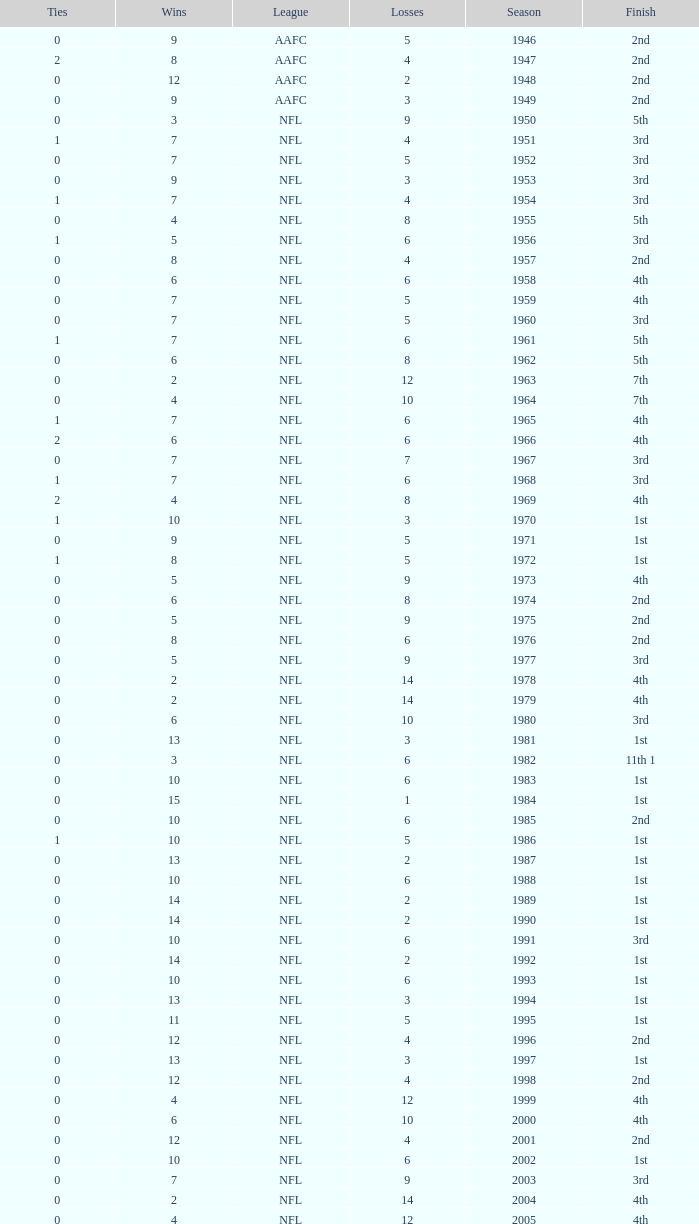What is the lowest number of ties in the NFL, with less than 2 losses and less than 15 wins? None. 